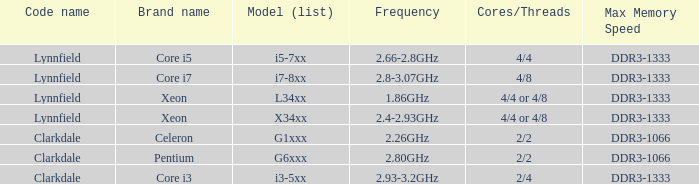What clock speed is used by the pentium processor? 2.80GHz. 